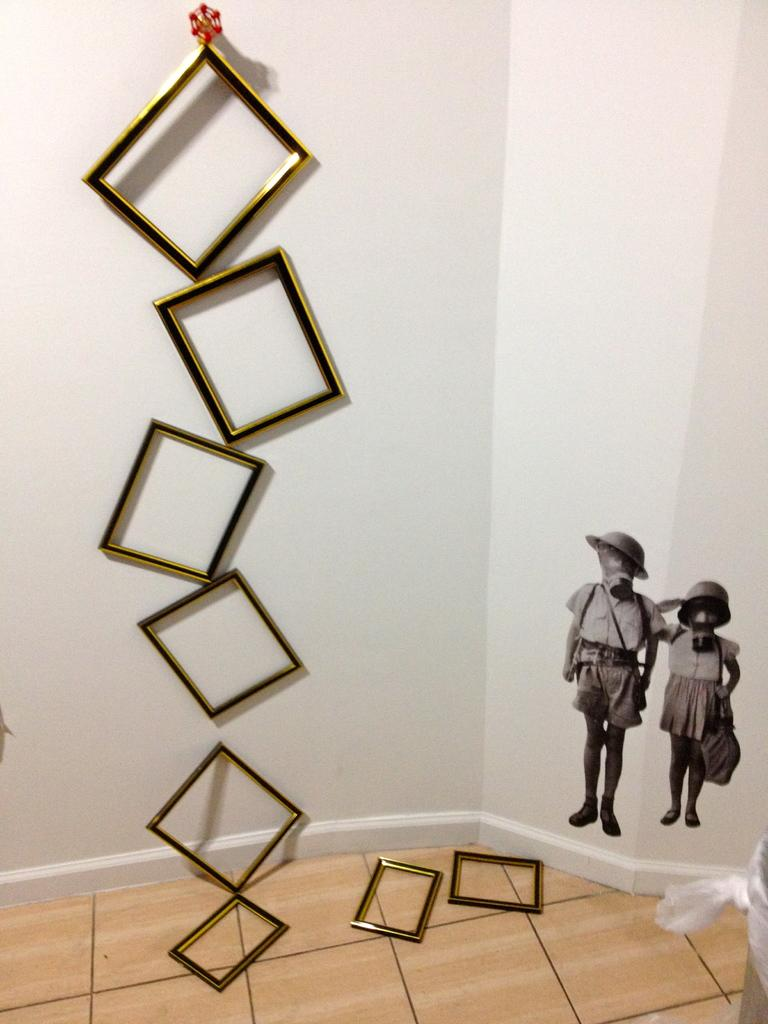What can be seen on the wall in the foreground of the image? There are frames on the wall in the foreground of the image. Are there any frames on the floor in the foreground of the image? Yes, some frames are on the floor in the foreground of the image. What is present on the right side of the wall in the image? There are stickers on the wall on the right side of the image. Can you describe the object located at the right bottom of the image? Unfortunately, the provided facts do not give enough information to describe the object at the right bottom of the image. What type of line can be seen connecting the frames on the wall in the image? There is no line connecting the frames on the wall in the image. Can you hear any bells ringing in the image? There is no mention of bells or any sounds in the image, so it cannot be determined if bells are ringing. 